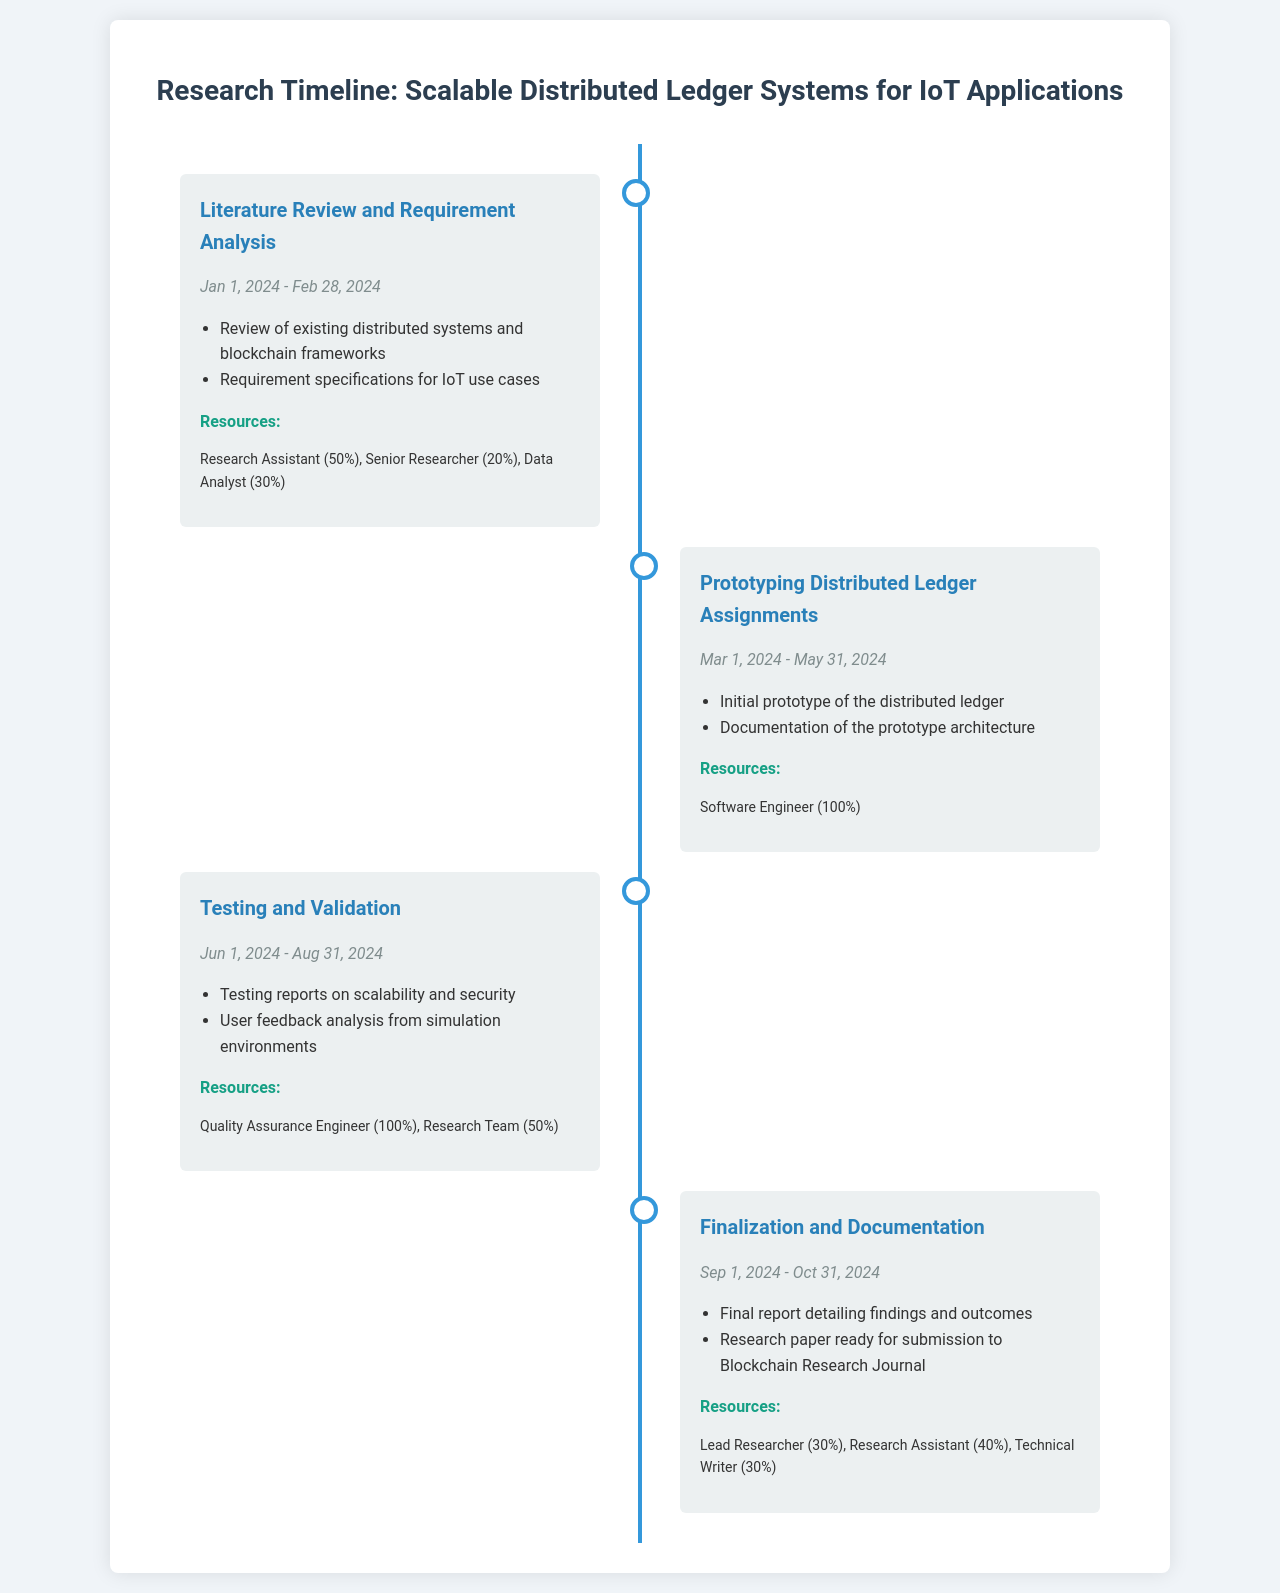What is the first milestone? The first milestone is the initial phase of the project, which focuses on the literature review and requirement analysis.
Answer: Literature Review and Requirement Analysis What is the duration of the Prototyping phase? The Prototyping phase starts on March 1, 2024 and ends on May 31, 2024, spanning a total of 3 months.
Answer: 3 months Which team is involved in the Testing phase? The Testing phase involves the Quality Assurance Engineer and the Research Team, as noted in the resources section of the milestone.
Answer: Quality Assurance Engineer, Research Team What is the end date of the Finalization phase? The Finalization phase concludes on October 31, 2024, marking the completion of the project documentation.
Answer: October 31, 2024 What percentage of the workload is allocated to the Research Assistant in the Literature Review phase? The workload allocated to the Research Assistant during the Literature Review phase is 50%.
Answer: 50% How many major milestones are outlined in the document? The document outlines four major milestones that guide the research timeline of the project.
Answer: Four What is a key deliverable of the Prototyping milestone? A key deliverable of the Prototyping milestone is the initial prototype of the distributed ledger.
Answer: Initial prototype of the distributed ledger Who is the lead researcher contributing to the Finalization phase? The lead researcher is one of the contributors during the Finalization phase, with a workload contribution of 30%.
Answer: Lead Researcher What is the focus of the Testing and Validation phase? The focus of the Testing and Validation phase is on scalability and security testing, along with user feedback analysis.
Answer: Scalability and security testing, user feedback analysis 